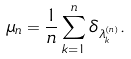<formula> <loc_0><loc_0><loc_500><loc_500>\mu _ { n } = \frac { 1 } { n } \sum _ { k = 1 } ^ { n } \delta _ { \lambda _ { k } ^ { ( n ) } } .</formula> 